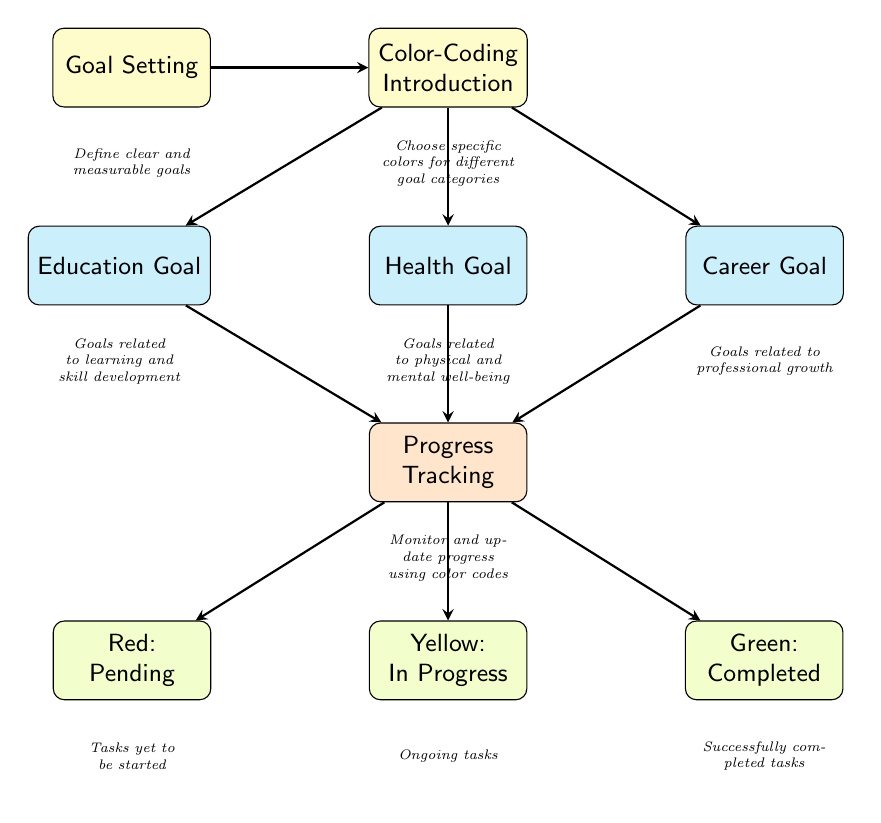What is the first node in the diagram? The first node in the diagram is labeled as "Goal Setting," which is the starting point of the flow.
Answer: Goal Setting How many main goal categories are shown? The diagram presents three main goal categories: Education, Health, and Career, which are connected to the color-coding introduction.
Answer: Three What color is associated with tasks that are in progress? The color associated with tasks that are in progress is yellow as indicated in the progress tracking section.
Answer: Yellow What does the green color represent in progress tracking? The green color represents completed tasks. This is explicitly stated in the progress tracking section of the diagram.
Answer: Completed Which node directly leads to progress tracking? The nodes that directly lead to progress tracking are Education Goal, Health Goal, and Career Goal, as they all connect to the progress tracking node.
Answer: Education Goal, Health Goal, Career Goal What is the purpose of the red color in the progress tracking? The red color denotes pending tasks, which are tasks that have yet to be started. This is a clear categorization in the color-coding system employed in the diagram.
Answer: Pending How many edges are connecting to the Progress Tracking node? There are five edges connecting to the Progress Tracking node. Three edges come from the goal categories (Education, Health, and Career), and two edges lead to the color-coded statuses (Red, Yellow, Green).
Answer: Five What does the color-coding introduction suggest about organizing goals? The color-coding introduction suggests that specific colors should be chosen for different goal categories to facilitate tracking and organization.
Answer: Choose specific colors Why is tracking progress beneficial according to the diagram? Tracking progress is beneficial as it allows individuals to monitor and update their tasks using a clear color-coded system, enhancing overall organization and clarity in managing personal development goals.
Answer: Monitor and update progress 